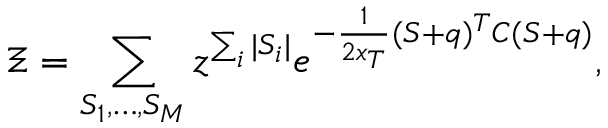Convert formula to latex. <formula><loc_0><loc_0><loc_500><loc_500>\Xi = \sum _ { S _ { 1 } , \dots , S _ { M } } z ^ { \sum _ { i } | S _ { i } | } e ^ { - \frac { 1 } { 2 x _ { T } } ( S + q ) ^ { T } C ( S + q ) } ,</formula> 